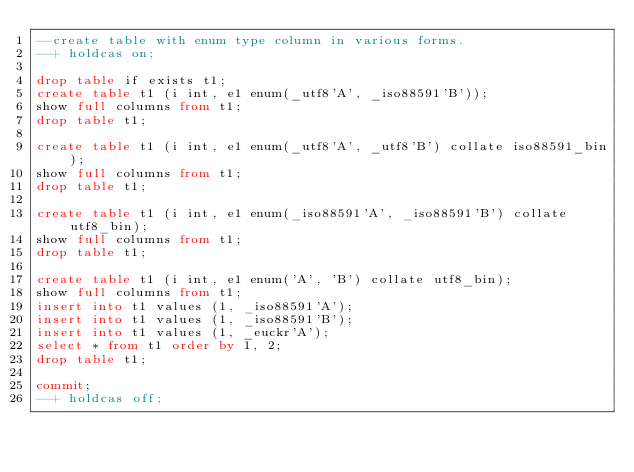Convert code to text. <code><loc_0><loc_0><loc_500><loc_500><_SQL_>--create table with enum type column in various forms.
--+ holdcas on;

drop table if exists t1;
create table t1 (i int, e1 enum(_utf8'A', _iso88591'B'));
show full columns from t1;
drop table t1;

create table t1 (i int, e1 enum(_utf8'A', _utf8'B') collate iso88591_bin);
show full columns from t1;
drop table t1;

create table t1 (i int, e1 enum(_iso88591'A', _iso88591'B') collate utf8_bin);
show full columns from t1;
drop table t1;

create table t1 (i int, e1 enum('A', 'B') collate utf8_bin);
show full columns from t1;
insert into t1 values (1, _iso88591'A');
insert into t1 values (1, _iso88591'B');
insert into t1 values (1, _euckr'A');
select * from t1 order by 1, 2;
drop table t1;

commit;
--+ holdcas off;
</code> 